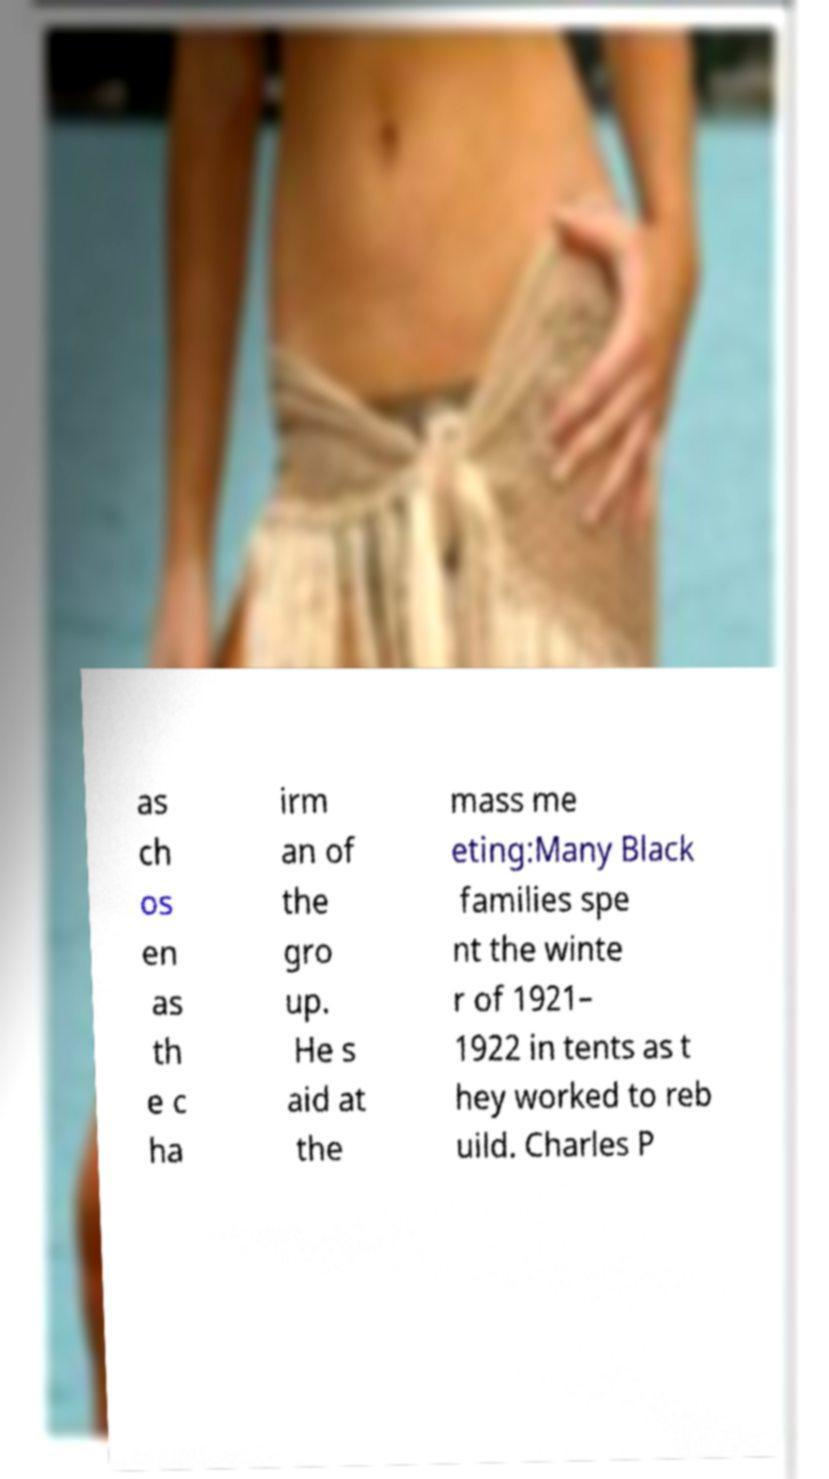Could you assist in decoding the text presented in this image and type it out clearly? as ch os en as th e c ha irm an of the gro up. He s aid at the mass me eting:Many Black families spe nt the winte r of 1921– 1922 in tents as t hey worked to reb uild. Charles P 